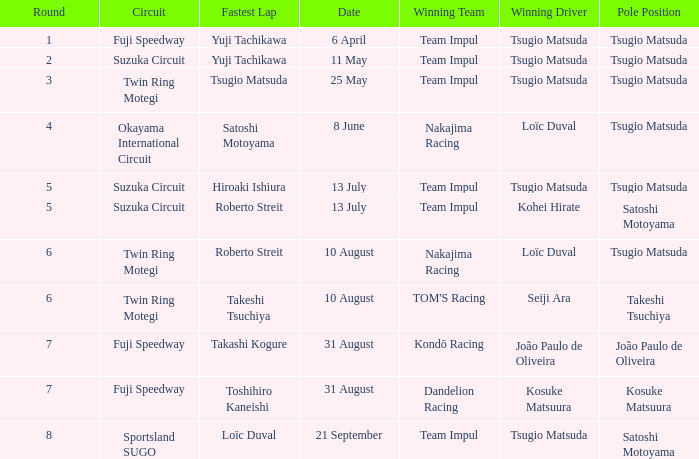On what date does Yuji Tachikawa have the fastest lap in round 1? 6 April. 